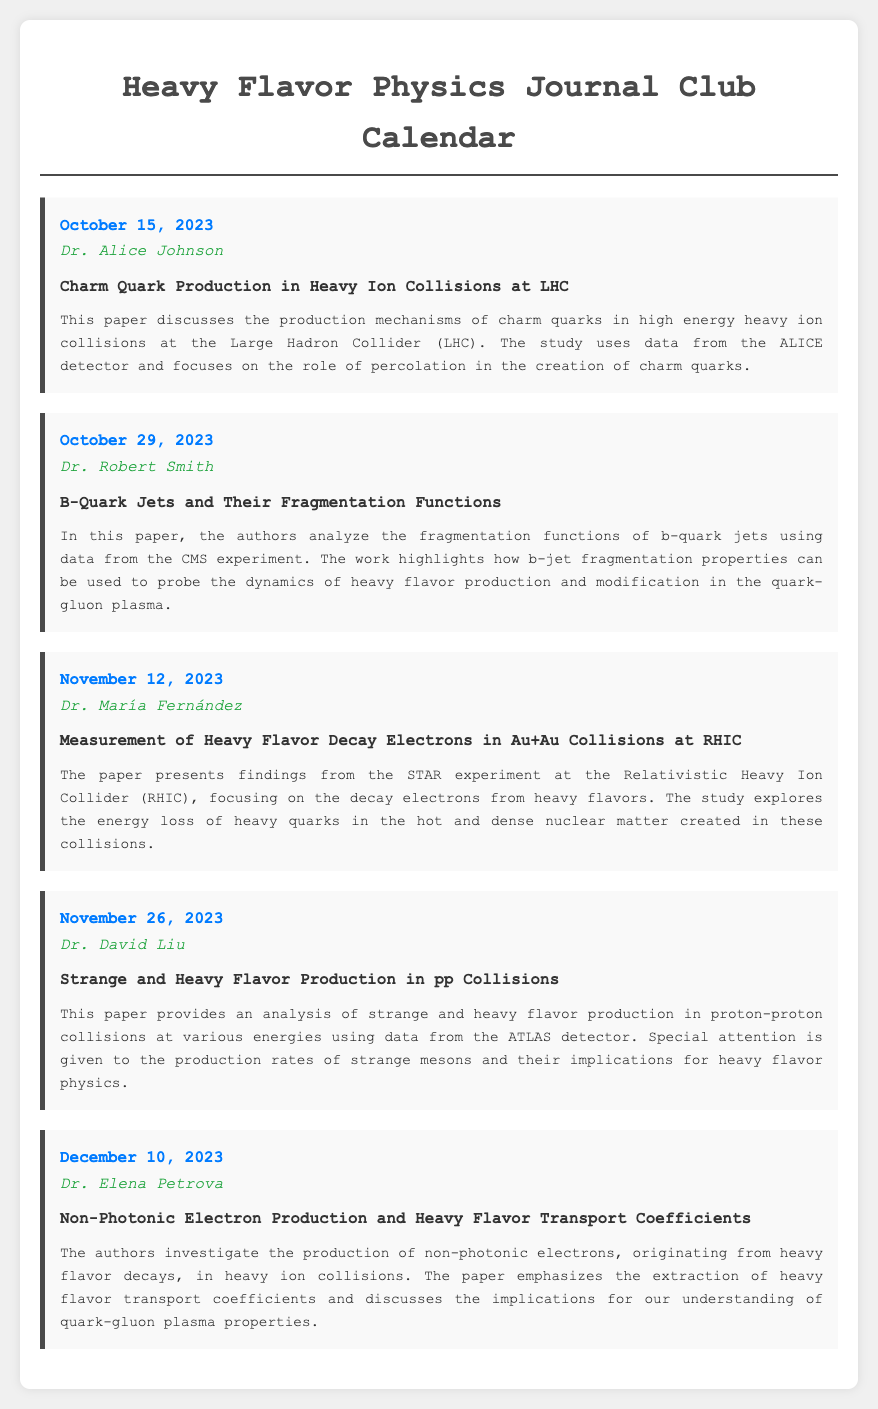What is the date of the first meeting? The first meeting is scheduled for October 15, 2023.
Answer: October 15, 2023 Who is presenting on October 29, 2023? The presenter for the meeting on October 29, 2023, is Dr. Robert Smith.
Answer: Dr. Robert Smith What is the title of the paper presented by Dr. María Fernández? The title of the paper presented by Dr. María Fernández is "Measurement of Heavy Flavor Decay Electrons in Au+Au Collisions at RHIC".
Answer: Measurement of Heavy Flavor Decay Electrons in Au+Au Collisions at RHIC How many presentations are scheduled in total? There are a total of five presentations listed in the calendar.
Answer: Five What do the authors investigate in the paper presented by Dr. Elena Petrova? The authors investigate the production of non-photonic electrons, originating from heavy flavor decays, in heavy ion collisions.
Answer: Non-photonic electrons production Who is the presenter for the last meeting on December 10, 2023? The presenter on December 10, 2023, is Dr. Elena Petrova.
Answer: Dr. Elena Petrova What is the focus of Dr. David Liu's paper? The focus of Dr. David Liu's paper is on strange and heavy flavor production in proton-proton collisions.
Answer: Strange and heavy flavor production What experiment's data is analyzed in Dr. Robert Smith's paper? Dr. Robert Smith's paper analyzes data from the CMS experiment.
Answer: CMS experiment Which paper discusses charm quark production? The paper discussing charm quark production is titled "Charm Quark Production in Heavy Ion Collisions at LHC".
Answer: Charm Quark Production in Heavy Ion Collisions at LHC 